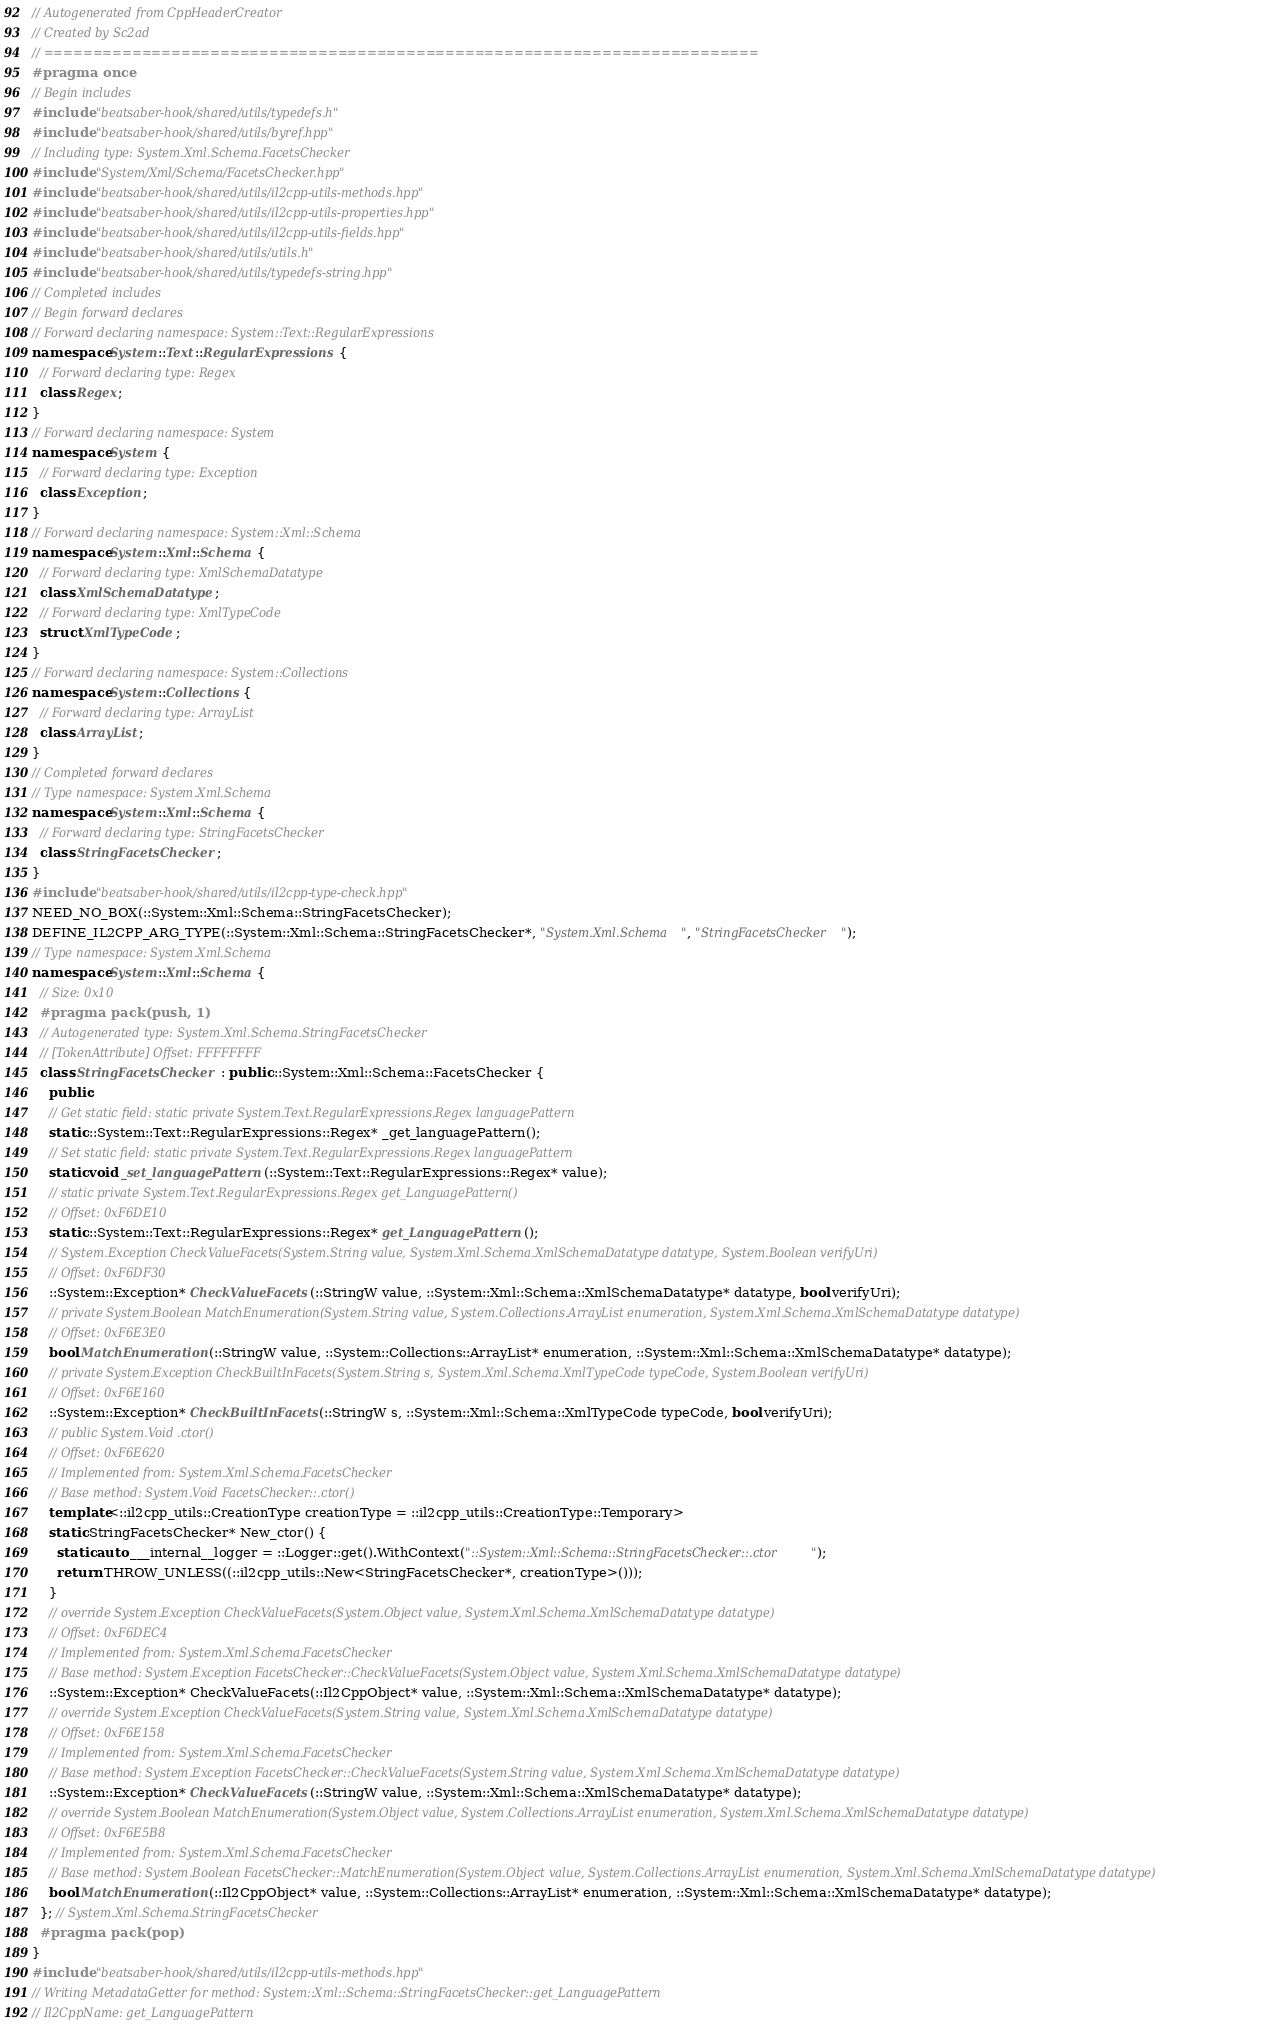<code> <loc_0><loc_0><loc_500><loc_500><_C++_>// Autogenerated from CppHeaderCreator
// Created by Sc2ad
// =========================================================================
#pragma once
// Begin includes
#include "beatsaber-hook/shared/utils/typedefs.h"
#include "beatsaber-hook/shared/utils/byref.hpp"
// Including type: System.Xml.Schema.FacetsChecker
#include "System/Xml/Schema/FacetsChecker.hpp"
#include "beatsaber-hook/shared/utils/il2cpp-utils-methods.hpp"
#include "beatsaber-hook/shared/utils/il2cpp-utils-properties.hpp"
#include "beatsaber-hook/shared/utils/il2cpp-utils-fields.hpp"
#include "beatsaber-hook/shared/utils/utils.h"
#include "beatsaber-hook/shared/utils/typedefs-string.hpp"
// Completed includes
// Begin forward declares
// Forward declaring namespace: System::Text::RegularExpressions
namespace System::Text::RegularExpressions {
  // Forward declaring type: Regex
  class Regex;
}
// Forward declaring namespace: System
namespace System {
  // Forward declaring type: Exception
  class Exception;
}
// Forward declaring namespace: System::Xml::Schema
namespace System::Xml::Schema {
  // Forward declaring type: XmlSchemaDatatype
  class XmlSchemaDatatype;
  // Forward declaring type: XmlTypeCode
  struct XmlTypeCode;
}
// Forward declaring namespace: System::Collections
namespace System::Collections {
  // Forward declaring type: ArrayList
  class ArrayList;
}
// Completed forward declares
// Type namespace: System.Xml.Schema
namespace System::Xml::Schema {
  // Forward declaring type: StringFacetsChecker
  class StringFacetsChecker;
}
#include "beatsaber-hook/shared/utils/il2cpp-type-check.hpp"
NEED_NO_BOX(::System::Xml::Schema::StringFacetsChecker);
DEFINE_IL2CPP_ARG_TYPE(::System::Xml::Schema::StringFacetsChecker*, "System.Xml.Schema", "StringFacetsChecker");
// Type namespace: System.Xml.Schema
namespace System::Xml::Schema {
  // Size: 0x10
  #pragma pack(push, 1)
  // Autogenerated type: System.Xml.Schema.StringFacetsChecker
  // [TokenAttribute] Offset: FFFFFFFF
  class StringFacetsChecker : public ::System::Xml::Schema::FacetsChecker {
    public:
    // Get static field: static private System.Text.RegularExpressions.Regex languagePattern
    static ::System::Text::RegularExpressions::Regex* _get_languagePattern();
    // Set static field: static private System.Text.RegularExpressions.Regex languagePattern
    static void _set_languagePattern(::System::Text::RegularExpressions::Regex* value);
    // static private System.Text.RegularExpressions.Regex get_LanguagePattern()
    // Offset: 0xF6DE10
    static ::System::Text::RegularExpressions::Regex* get_LanguagePattern();
    // System.Exception CheckValueFacets(System.String value, System.Xml.Schema.XmlSchemaDatatype datatype, System.Boolean verifyUri)
    // Offset: 0xF6DF30
    ::System::Exception* CheckValueFacets(::StringW value, ::System::Xml::Schema::XmlSchemaDatatype* datatype, bool verifyUri);
    // private System.Boolean MatchEnumeration(System.String value, System.Collections.ArrayList enumeration, System.Xml.Schema.XmlSchemaDatatype datatype)
    // Offset: 0xF6E3E0
    bool MatchEnumeration(::StringW value, ::System::Collections::ArrayList* enumeration, ::System::Xml::Schema::XmlSchemaDatatype* datatype);
    // private System.Exception CheckBuiltInFacets(System.String s, System.Xml.Schema.XmlTypeCode typeCode, System.Boolean verifyUri)
    // Offset: 0xF6E160
    ::System::Exception* CheckBuiltInFacets(::StringW s, ::System::Xml::Schema::XmlTypeCode typeCode, bool verifyUri);
    // public System.Void .ctor()
    // Offset: 0xF6E620
    // Implemented from: System.Xml.Schema.FacetsChecker
    // Base method: System.Void FacetsChecker::.ctor()
    template<::il2cpp_utils::CreationType creationType = ::il2cpp_utils::CreationType::Temporary>
    static StringFacetsChecker* New_ctor() {
      static auto ___internal__logger = ::Logger::get().WithContext("::System::Xml::Schema::StringFacetsChecker::.ctor");
      return THROW_UNLESS((::il2cpp_utils::New<StringFacetsChecker*, creationType>()));
    }
    // override System.Exception CheckValueFacets(System.Object value, System.Xml.Schema.XmlSchemaDatatype datatype)
    // Offset: 0xF6DEC4
    // Implemented from: System.Xml.Schema.FacetsChecker
    // Base method: System.Exception FacetsChecker::CheckValueFacets(System.Object value, System.Xml.Schema.XmlSchemaDatatype datatype)
    ::System::Exception* CheckValueFacets(::Il2CppObject* value, ::System::Xml::Schema::XmlSchemaDatatype* datatype);
    // override System.Exception CheckValueFacets(System.String value, System.Xml.Schema.XmlSchemaDatatype datatype)
    // Offset: 0xF6E158
    // Implemented from: System.Xml.Schema.FacetsChecker
    // Base method: System.Exception FacetsChecker::CheckValueFacets(System.String value, System.Xml.Schema.XmlSchemaDatatype datatype)
    ::System::Exception* CheckValueFacets(::StringW value, ::System::Xml::Schema::XmlSchemaDatatype* datatype);
    // override System.Boolean MatchEnumeration(System.Object value, System.Collections.ArrayList enumeration, System.Xml.Schema.XmlSchemaDatatype datatype)
    // Offset: 0xF6E5B8
    // Implemented from: System.Xml.Schema.FacetsChecker
    // Base method: System.Boolean FacetsChecker::MatchEnumeration(System.Object value, System.Collections.ArrayList enumeration, System.Xml.Schema.XmlSchemaDatatype datatype)
    bool MatchEnumeration(::Il2CppObject* value, ::System::Collections::ArrayList* enumeration, ::System::Xml::Schema::XmlSchemaDatatype* datatype);
  }; // System.Xml.Schema.StringFacetsChecker
  #pragma pack(pop)
}
#include "beatsaber-hook/shared/utils/il2cpp-utils-methods.hpp"
// Writing MetadataGetter for method: System::Xml::Schema::StringFacetsChecker::get_LanguagePattern
// Il2CppName: get_LanguagePattern</code> 